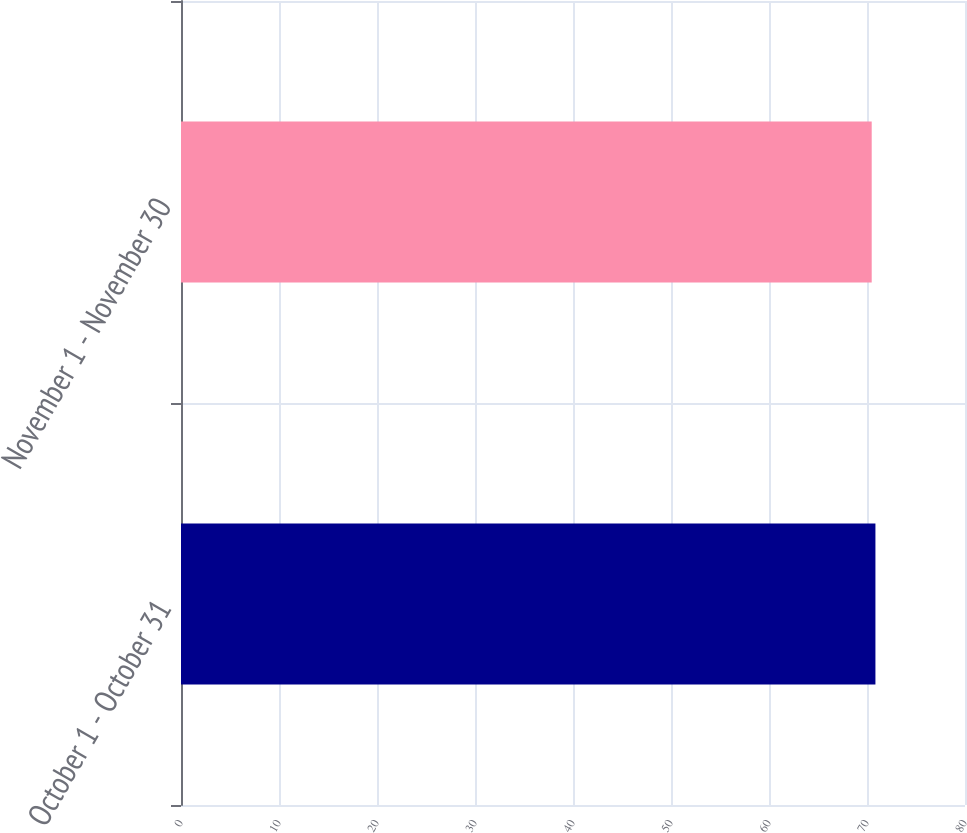<chart> <loc_0><loc_0><loc_500><loc_500><bar_chart><fcel>October 1 - October 31<fcel>November 1 - November 30<nl><fcel>70.86<fcel>70.48<nl></chart> 